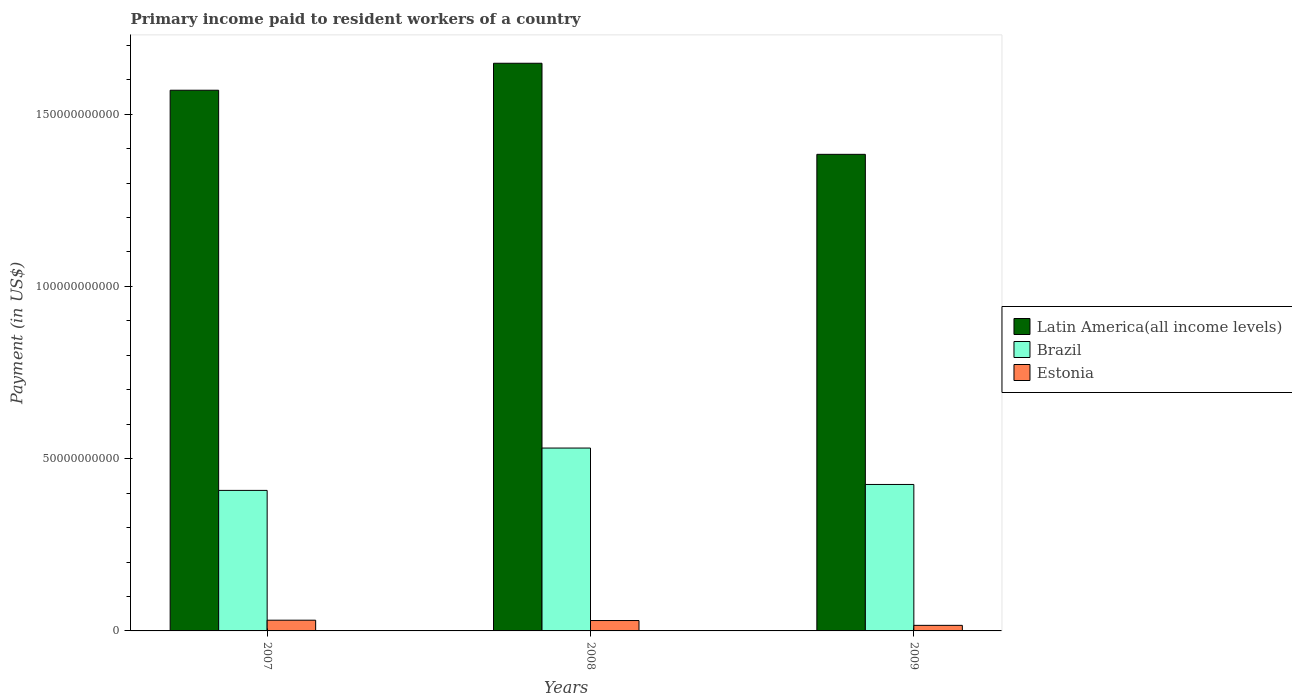How many different coloured bars are there?
Offer a very short reply. 3. How many groups of bars are there?
Provide a short and direct response. 3. Are the number of bars on each tick of the X-axis equal?
Provide a succinct answer. Yes. How many bars are there on the 1st tick from the left?
Keep it short and to the point. 3. What is the label of the 2nd group of bars from the left?
Your answer should be very brief. 2008. What is the amount paid to workers in Brazil in 2007?
Your response must be concise. 4.08e+1. Across all years, what is the maximum amount paid to workers in Latin America(all income levels)?
Ensure brevity in your answer.  1.65e+11. Across all years, what is the minimum amount paid to workers in Brazil?
Ensure brevity in your answer.  4.08e+1. In which year was the amount paid to workers in Brazil minimum?
Provide a short and direct response. 2007. What is the total amount paid to workers in Brazil in the graph?
Your response must be concise. 1.36e+11. What is the difference between the amount paid to workers in Estonia in 2008 and that in 2009?
Your response must be concise. 1.40e+09. What is the difference between the amount paid to workers in Estonia in 2007 and the amount paid to workers in Latin America(all income levels) in 2009?
Keep it short and to the point. -1.35e+11. What is the average amount paid to workers in Latin America(all income levels) per year?
Your answer should be compact. 1.53e+11. In the year 2008, what is the difference between the amount paid to workers in Estonia and amount paid to workers in Latin America(all income levels)?
Provide a succinct answer. -1.62e+11. What is the ratio of the amount paid to workers in Brazil in 2008 to that in 2009?
Your answer should be compact. 1.25. Is the amount paid to workers in Brazil in 2008 less than that in 2009?
Your answer should be compact. No. What is the difference between the highest and the second highest amount paid to workers in Estonia?
Offer a very short reply. 9.80e+07. What is the difference between the highest and the lowest amount paid to workers in Brazil?
Make the answer very short. 1.23e+1. Is the sum of the amount paid to workers in Brazil in 2007 and 2009 greater than the maximum amount paid to workers in Estonia across all years?
Keep it short and to the point. Yes. What does the 2nd bar from the left in 2008 represents?
Keep it short and to the point. Brazil. What does the 3rd bar from the right in 2007 represents?
Provide a succinct answer. Latin America(all income levels). Are all the bars in the graph horizontal?
Your answer should be very brief. No. Does the graph contain grids?
Provide a succinct answer. No. How many legend labels are there?
Your response must be concise. 3. What is the title of the graph?
Give a very brief answer. Primary income paid to resident workers of a country. Does "Finland" appear as one of the legend labels in the graph?
Offer a terse response. No. What is the label or title of the X-axis?
Offer a terse response. Years. What is the label or title of the Y-axis?
Offer a very short reply. Payment (in US$). What is the Payment (in US$) of Latin America(all income levels) in 2007?
Keep it short and to the point. 1.57e+11. What is the Payment (in US$) of Brazil in 2007?
Offer a terse response. 4.08e+1. What is the Payment (in US$) of Estonia in 2007?
Provide a short and direct response. 3.11e+09. What is the Payment (in US$) of Latin America(all income levels) in 2008?
Make the answer very short. 1.65e+11. What is the Payment (in US$) in Brazil in 2008?
Make the answer very short. 5.31e+1. What is the Payment (in US$) of Estonia in 2008?
Offer a very short reply. 3.01e+09. What is the Payment (in US$) of Latin America(all income levels) in 2009?
Offer a very short reply. 1.38e+11. What is the Payment (in US$) of Brazil in 2009?
Give a very brief answer. 4.25e+1. What is the Payment (in US$) of Estonia in 2009?
Provide a succinct answer. 1.62e+09. Across all years, what is the maximum Payment (in US$) of Latin America(all income levels)?
Keep it short and to the point. 1.65e+11. Across all years, what is the maximum Payment (in US$) in Brazil?
Make the answer very short. 5.31e+1. Across all years, what is the maximum Payment (in US$) in Estonia?
Provide a short and direct response. 3.11e+09. Across all years, what is the minimum Payment (in US$) in Latin America(all income levels)?
Provide a succinct answer. 1.38e+11. Across all years, what is the minimum Payment (in US$) in Brazil?
Give a very brief answer. 4.08e+1. Across all years, what is the minimum Payment (in US$) of Estonia?
Keep it short and to the point. 1.62e+09. What is the total Payment (in US$) in Latin America(all income levels) in the graph?
Your response must be concise. 4.60e+11. What is the total Payment (in US$) in Brazil in the graph?
Provide a succinct answer. 1.36e+11. What is the total Payment (in US$) in Estonia in the graph?
Provide a succinct answer. 7.74e+09. What is the difference between the Payment (in US$) in Latin America(all income levels) in 2007 and that in 2008?
Your answer should be compact. -7.83e+09. What is the difference between the Payment (in US$) of Brazil in 2007 and that in 2008?
Ensure brevity in your answer.  -1.23e+1. What is the difference between the Payment (in US$) in Estonia in 2007 and that in 2008?
Provide a short and direct response. 9.80e+07. What is the difference between the Payment (in US$) in Latin America(all income levels) in 2007 and that in 2009?
Make the answer very short. 1.86e+1. What is the difference between the Payment (in US$) of Brazil in 2007 and that in 2009?
Make the answer very short. -1.73e+09. What is the difference between the Payment (in US$) of Estonia in 2007 and that in 2009?
Make the answer very short. 1.50e+09. What is the difference between the Payment (in US$) of Latin America(all income levels) in 2008 and that in 2009?
Your response must be concise. 2.64e+1. What is the difference between the Payment (in US$) of Brazil in 2008 and that in 2009?
Provide a succinct answer. 1.06e+1. What is the difference between the Payment (in US$) in Estonia in 2008 and that in 2009?
Offer a terse response. 1.40e+09. What is the difference between the Payment (in US$) in Latin America(all income levels) in 2007 and the Payment (in US$) in Brazil in 2008?
Offer a terse response. 1.04e+11. What is the difference between the Payment (in US$) in Latin America(all income levels) in 2007 and the Payment (in US$) in Estonia in 2008?
Make the answer very short. 1.54e+11. What is the difference between the Payment (in US$) in Brazil in 2007 and the Payment (in US$) in Estonia in 2008?
Offer a terse response. 3.78e+1. What is the difference between the Payment (in US$) of Latin America(all income levels) in 2007 and the Payment (in US$) of Brazil in 2009?
Provide a short and direct response. 1.14e+11. What is the difference between the Payment (in US$) in Latin America(all income levels) in 2007 and the Payment (in US$) in Estonia in 2009?
Ensure brevity in your answer.  1.55e+11. What is the difference between the Payment (in US$) in Brazil in 2007 and the Payment (in US$) in Estonia in 2009?
Your response must be concise. 3.92e+1. What is the difference between the Payment (in US$) of Latin America(all income levels) in 2008 and the Payment (in US$) of Brazil in 2009?
Provide a short and direct response. 1.22e+11. What is the difference between the Payment (in US$) of Latin America(all income levels) in 2008 and the Payment (in US$) of Estonia in 2009?
Keep it short and to the point. 1.63e+11. What is the difference between the Payment (in US$) in Brazil in 2008 and the Payment (in US$) in Estonia in 2009?
Offer a terse response. 5.15e+1. What is the average Payment (in US$) of Latin America(all income levels) per year?
Offer a very short reply. 1.53e+11. What is the average Payment (in US$) of Brazil per year?
Keep it short and to the point. 4.55e+1. What is the average Payment (in US$) in Estonia per year?
Give a very brief answer. 2.58e+09. In the year 2007, what is the difference between the Payment (in US$) of Latin America(all income levels) and Payment (in US$) of Brazil?
Ensure brevity in your answer.  1.16e+11. In the year 2007, what is the difference between the Payment (in US$) of Latin America(all income levels) and Payment (in US$) of Estonia?
Your answer should be compact. 1.54e+11. In the year 2007, what is the difference between the Payment (in US$) of Brazil and Payment (in US$) of Estonia?
Give a very brief answer. 3.77e+1. In the year 2008, what is the difference between the Payment (in US$) of Latin America(all income levels) and Payment (in US$) of Brazil?
Your response must be concise. 1.12e+11. In the year 2008, what is the difference between the Payment (in US$) of Latin America(all income levels) and Payment (in US$) of Estonia?
Your answer should be compact. 1.62e+11. In the year 2008, what is the difference between the Payment (in US$) of Brazil and Payment (in US$) of Estonia?
Offer a terse response. 5.01e+1. In the year 2009, what is the difference between the Payment (in US$) of Latin America(all income levels) and Payment (in US$) of Brazil?
Your answer should be compact. 9.58e+1. In the year 2009, what is the difference between the Payment (in US$) in Latin America(all income levels) and Payment (in US$) in Estonia?
Your answer should be very brief. 1.37e+11. In the year 2009, what is the difference between the Payment (in US$) of Brazil and Payment (in US$) of Estonia?
Your response must be concise. 4.09e+1. What is the ratio of the Payment (in US$) of Latin America(all income levels) in 2007 to that in 2008?
Your answer should be compact. 0.95. What is the ratio of the Payment (in US$) in Brazil in 2007 to that in 2008?
Your answer should be compact. 0.77. What is the ratio of the Payment (in US$) in Estonia in 2007 to that in 2008?
Offer a very short reply. 1.03. What is the ratio of the Payment (in US$) in Latin America(all income levels) in 2007 to that in 2009?
Make the answer very short. 1.13. What is the ratio of the Payment (in US$) of Brazil in 2007 to that in 2009?
Make the answer very short. 0.96. What is the ratio of the Payment (in US$) in Estonia in 2007 to that in 2009?
Give a very brief answer. 1.93. What is the ratio of the Payment (in US$) of Latin America(all income levels) in 2008 to that in 2009?
Offer a terse response. 1.19. What is the ratio of the Payment (in US$) in Brazil in 2008 to that in 2009?
Offer a very short reply. 1.25. What is the ratio of the Payment (in US$) of Estonia in 2008 to that in 2009?
Ensure brevity in your answer.  1.87. What is the difference between the highest and the second highest Payment (in US$) of Latin America(all income levels)?
Make the answer very short. 7.83e+09. What is the difference between the highest and the second highest Payment (in US$) of Brazil?
Provide a short and direct response. 1.06e+1. What is the difference between the highest and the second highest Payment (in US$) in Estonia?
Your answer should be very brief. 9.80e+07. What is the difference between the highest and the lowest Payment (in US$) in Latin America(all income levels)?
Your response must be concise. 2.64e+1. What is the difference between the highest and the lowest Payment (in US$) of Brazil?
Offer a terse response. 1.23e+1. What is the difference between the highest and the lowest Payment (in US$) in Estonia?
Offer a very short reply. 1.50e+09. 